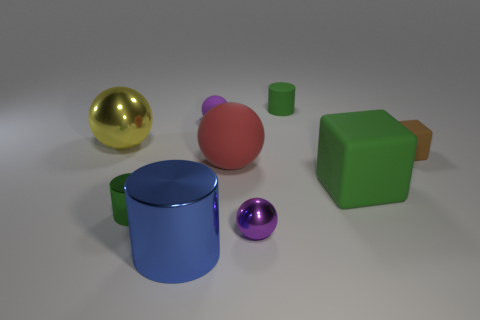How many other things are the same color as the large cube?
Provide a short and direct response. 2. Does the green cylinder that is left of the blue metallic thing have the same material as the small block?
Make the answer very short. No. What is the red ball in front of the matte cylinder made of?
Make the answer very short. Rubber. There is a metallic object that is behind the small green thing in front of the large green rubber block; what is its size?
Keep it short and to the point. Large. Is there a red sphere made of the same material as the small brown object?
Provide a succinct answer. Yes. What shape is the small matte object that is in front of the metal sphere to the left of the metal ball that is in front of the large green block?
Offer a terse response. Cube. There is a tiny sphere on the left side of the large red ball; does it have the same color as the small object left of the big metal cylinder?
Offer a very short reply. No. Is there anything else that has the same size as the blue metallic cylinder?
Your answer should be compact. Yes. Are there any matte balls in front of the large block?
Provide a short and direct response. No. How many small brown objects have the same shape as the blue shiny object?
Keep it short and to the point. 0. 